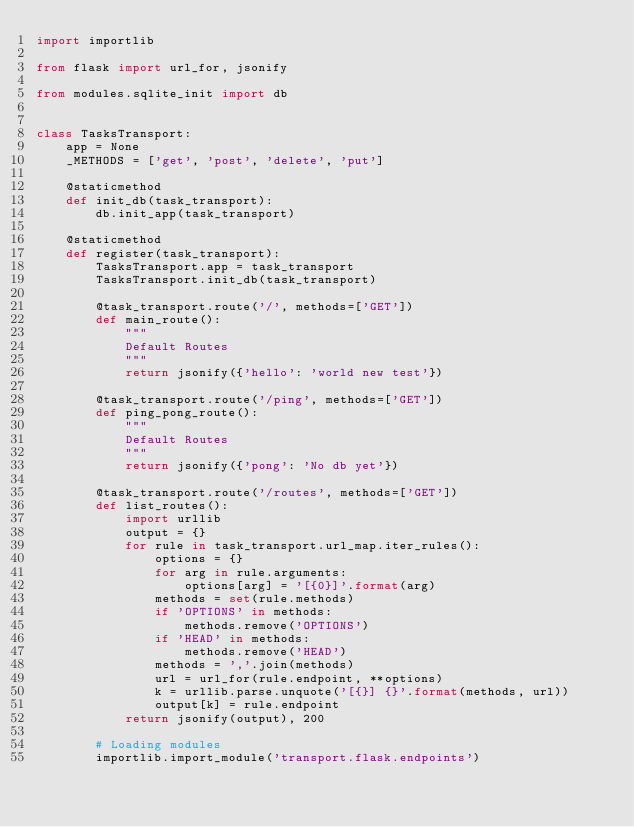<code> <loc_0><loc_0><loc_500><loc_500><_Python_>import importlib

from flask import url_for, jsonify

from modules.sqlite_init import db


class TasksTransport:
    app = None
    _METHODS = ['get', 'post', 'delete', 'put']

    @staticmethod
    def init_db(task_transport):
        db.init_app(task_transport)

    @staticmethod
    def register(task_transport):
        TasksTransport.app = task_transport
        TasksTransport.init_db(task_transport)

        @task_transport.route('/', methods=['GET'])
        def main_route():
            """
            Default Routes
            """
            return jsonify({'hello': 'world new test'})

        @task_transport.route('/ping', methods=['GET'])
        def ping_pong_route():
            """
            Default Routes
            """
            return jsonify({'pong': 'No db yet'})

        @task_transport.route('/routes', methods=['GET'])
        def list_routes():
            import urllib
            output = {}
            for rule in task_transport.url_map.iter_rules():
                options = {}
                for arg in rule.arguments:
                    options[arg] = '[{0}]'.format(arg)
                methods = set(rule.methods)
                if 'OPTIONS' in methods:
                    methods.remove('OPTIONS')
                if 'HEAD' in methods:
                    methods.remove('HEAD')
                methods = ','.join(methods)
                url = url_for(rule.endpoint, **options)
                k = urllib.parse.unquote('[{}] {}'.format(methods, url))
                output[k] = rule.endpoint
            return jsonify(output), 200

        # Loading modules
        importlib.import_module('transport.flask.endpoints')
</code> 